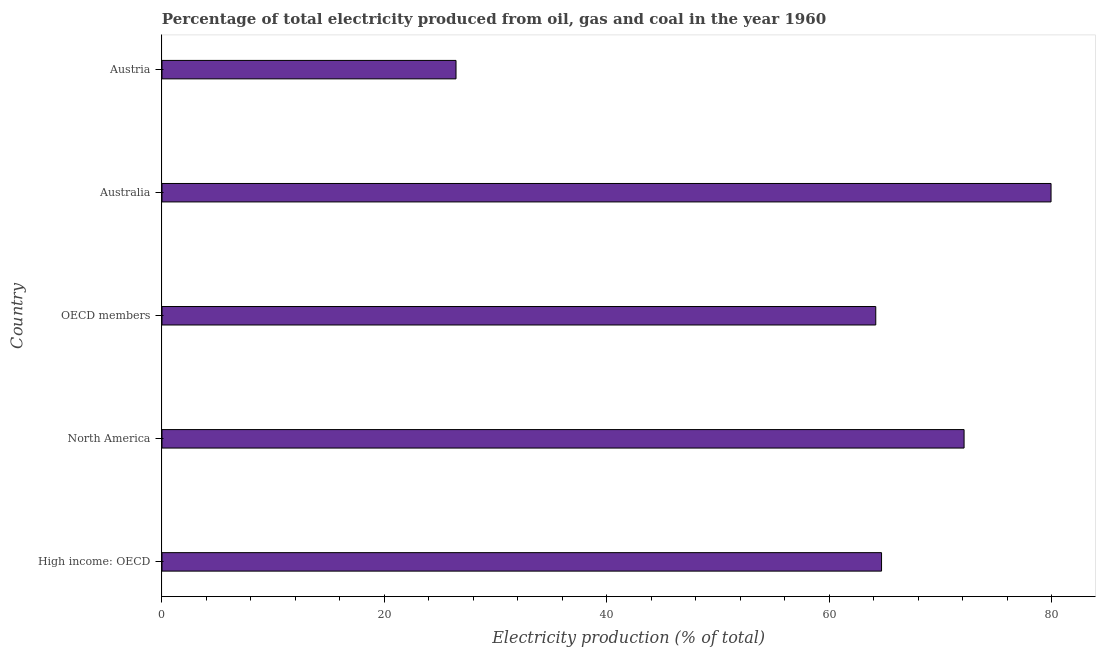Does the graph contain any zero values?
Your answer should be very brief. No. What is the title of the graph?
Keep it short and to the point. Percentage of total electricity produced from oil, gas and coal in the year 1960. What is the label or title of the X-axis?
Your answer should be compact. Electricity production (% of total). What is the electricity production in Austria?
Offer a very short reply. 26.44. Across all countries, what is the maximum electricity production?
Ensure brevity in your answer.  79.95. Across all countries, what is the minimum electricity production?
Give a very brief answer. 26.44. In which country was the electricity production maximum?
Make the answer very short. Australia. What is the sum of the electricity production?
Give a very brief answer. 307.41. What is the difference between the electricity production in North America and OECD members?
Your answer should be very brief. 7.94. What is the average electricity production per country?
Your answer should be very brief. 61.48. What is the median electricity production?
Offer a terse response. 64.71. In how many countries, is the electricity production greater than 36 %?
Provide a short and direct response. 4. What is the ratio of the electricity production in Australia to that in High income: OECD?
Your answer should be very brief. 1.24. Is the difference between the electricity production in Australia and High income: OECD greater than the difference between any two countries?
Make the answer very short. No. What is the difference between the highest and the second highest electricity production?
Provide a succinct answer. 7.82. What is the difference between the highest and the lowest electricity production?
Provide a short and direct response. 53.51. How many countries are there in the graph?
Keep it short and to the point. 5. Are the values on the major ticks of X-axis written in scientific E-notation?
Ensure brevity in your answer.  No. What is the Electricity production (% of total) in High income: OECD?
Your response must be concise. 64.71. What is the Electricity production (% of total) of North America?
Make the answer very short. 72.13. What is the Electricity production (% of total) in OECD members?
Ensure brevity in your answer.  64.19. What is the Electricity production (% of total) in Australia?
Your answer should be very brief. 79.95. What is the Electricity production (% of total) in Austria?
Provide a succinct answer. 26.44. What is the difference between the Electricity production (% of total) in High income: OECD and North America?
Offer a very short reply. -7.42. What is the difference between the Electricity production (% of total) in High income: OECD and OECD members?
Offer a very short reply. 0.52. What is the difference between the Electricity production (% of total) in High income: OECD and Australia?
Offer a terse response. -15.24. What is the difference between the Electricity production (% of total) in High income: OECD and Austria?
Provide a short and direct response. 38.26. What is the difference between the Electricity production (% of total) in North America and OECD members?
Provide a succinct answer. 7.94. What is the difference between the Electricity production (% of total) in North America and Australia?
Your answer should be very brief. -7.82. What is the difference between the Electricity production (% of total) in North America and Austria?
Ensure brevity in your answer.  45.69. What is the difference between the Electricity production (% of total) in OECD members and Australia?
Your answer should be very brief. -15.76. What is the difference between the Electricity production (% of total) in OECD members and Austria?
Your response must be concise. 37.74. What is the difference between the Electricity production (% of total) in Australia and Austria?
Your response must be concise. 53.51. What is the ratio of the Electricity production (% of total) in High income: OECD to that in North America?
Offer a terse response. 0.9. What is the ratio of the Electricity production (% of total) in High income: OECD to that in Australia?
Offer a very short reply. 0.81. What is the ratio of the Electricity production (% of total) in High income: OECD to that in Austria?
Your response must be concise. 2.45. What is the ratio of the Electricity production (% of total) in North America to that in OECD members?
Your answer should be very brief. 1.12. What is the ratio of the Electricity production (% of total) in North America to that in Australia?
Provide a short and direct response. 0.9. What is the ratio of the Electricity production (% of total) in North America to that in Austria?
Provide a short and direct response. 2.73. What is the ratio of the Electricity production (% of total) in OECD members to that in Australia?
Offer a terse response. 0.8. What is the ratio of the Electricity production (% of total) in OECD members to that in Austria?
Your answer should be very brief. 2.43. What is the ratio of the Electricity production (% of total) in Australia to that in Austria?
Offer a terse response. 3.02. 